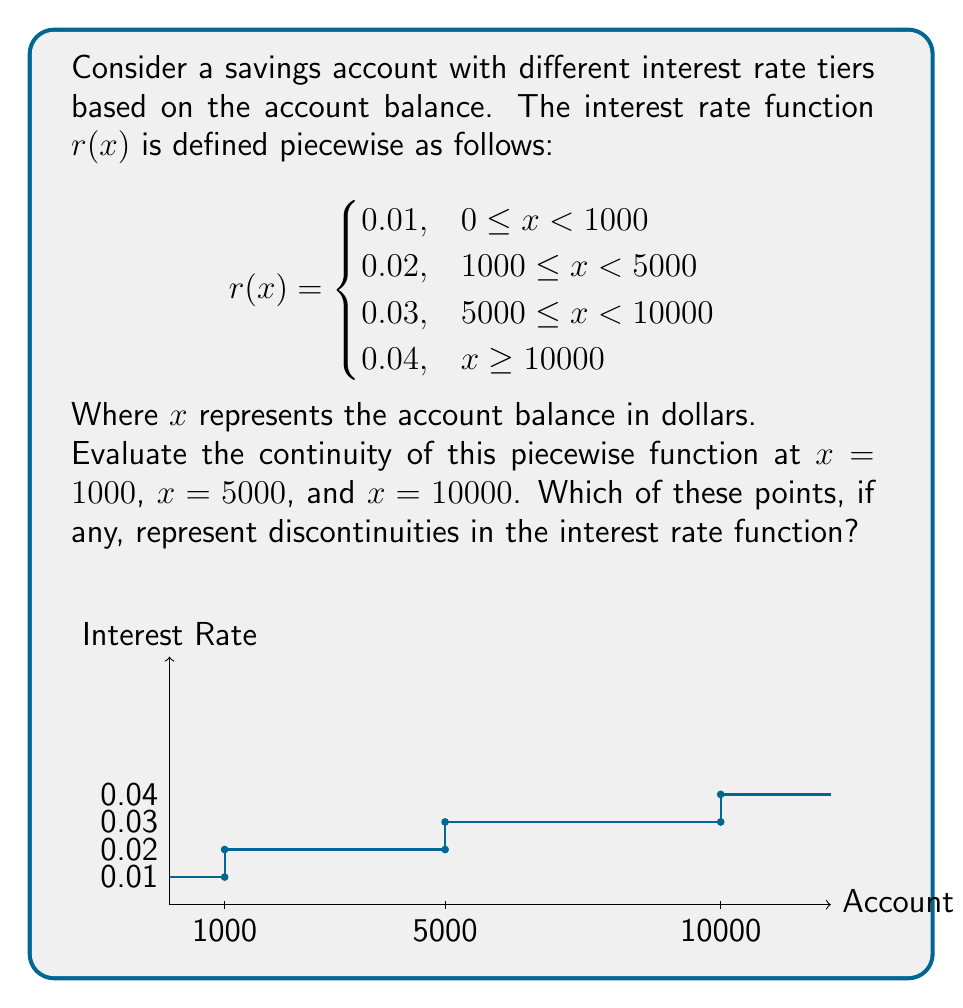Can you answer this question? To evaluate the continuity of the piecewise function at the given points, we need to check if the function satisfies the three conditions for continuity at each point:

1. The function is defined at the point.
2. The limit of the function as we approach the point from both sides exists.
3. The limit equals the function value at that point.

Let's examine each point:

1. At $x = 1000$:
   - Left limit: $\lim_{x \to 1000^-} r(x) = 0.01$
   - Right limit: $\lim_{x \to 1000^+} r(x) = 0.02$
   - Function value: $r(1000) = 0.02$
   
   The left limit doesn't equal the right limit, so the function is discontinuous at $x = 1000$.

2. At $x = 5000$:
   - Left limit: $\lim_{x \to 5000^-} r(x) = 0.02$
   - Right limit: $\lim_{x \to 5000^+} r(x) = 0.03$
   - Function value: $r(5000) = 0.03$
   
   The left limit doesn't equal the right limit, so the function is discontinuous at $x = 5000$.

3. At $x = 10000$:
   - Left limit: $\lim_{x \to 10000^-} r(x) = 0.03$
   - Right limit: $\lim_{x \to 10000^+} r(x) = 0.04$
   - Function value: $r(10000) = 0.04$
   
   The left limit doesn't equal the right limit, so the function is discontinuous at $x = 10000$.

In all three cases, we have jump discontinuities where the interest rate changes abruptly as the account balance crosses the threshold for a new tier.
Answer: The function is discontinuous at $x = 1000$, $x = 5000$, and $x = 10000$. 